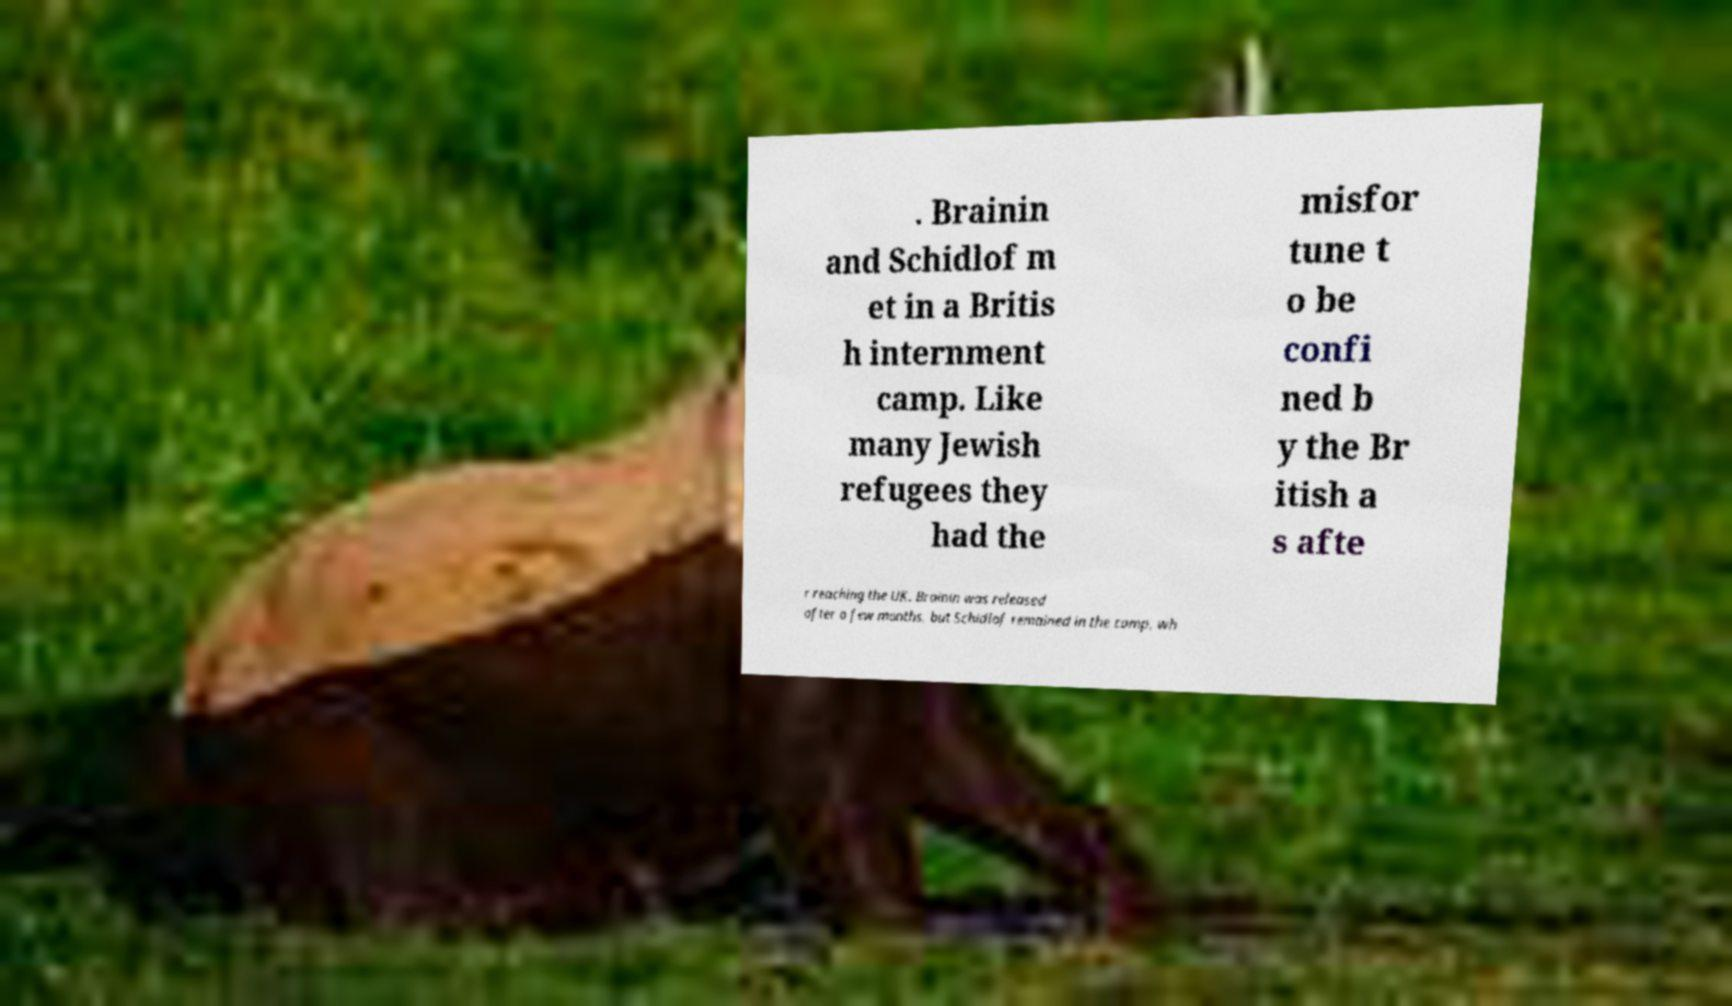I need the written content from this picture converted into text. Can you do that? . Brainin and Schidlof m et in a Britis h internment camp. Like many Jewish refugees they had the misfor tune t o be confi ned b y the Br itish a s afte r reaching the UK. Brainin was released after a few months, but Schidlof remained in the camp, wh 